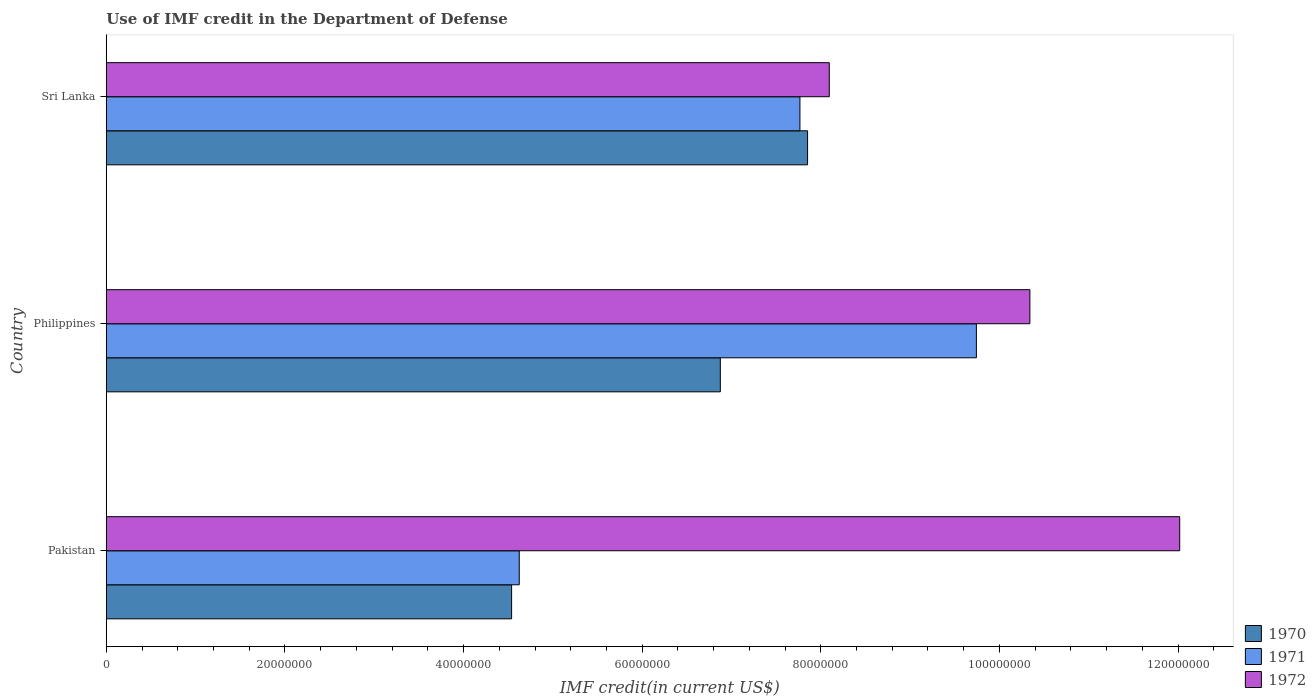How many different coloured bars are there?
Keep it short and to the point. 3. Are the number of bars per tick equal to the number of legend labels?
Provide a succinct answer. Yes. Are the number of bars on each tick of the Y-axis equal?
Make the answer very short. Yes. What is the label of the 3rd group of bars from the top?
Keep it short and to the point. Pakistan. What is the IMF credit in the Department of Defense in 1971 in Sri Lanka?
Ensure brevity in your answer.  7.77e+07. Across all countries, what is the maximum IMF credit in the Department of Defense in 1971?
Your response must be concise. 9.74e+07. Across all countries, what is the minimum IMF credit in the Department of Defense in 1972?
Keep it short and to the point. 8.10e+07. What is the total IMF credit in the Department of Defense in 1971 in the graph?
Your answer should be compact. 2.21e+08. What is the difference between the IMF credit in the Department of Defense in 1970 in Pakistan and that in Sri Lanka?
Your answer should be very brief. -3.31e+07. What is the difference between the IMF credit in the Department of Defense in 1971 in Sri Lanka and the IMF credit in the Department of Defense in 1970 in Philippines?
Your answer should be very brief. 8.91e+06. What is the average IMF credit in the Department of Defense in 1972 per country?
Your response must be concise. 1.02e+08. What is the difference between the IMF credit in the Department of Defense in 1970 and IMF credit in the Department of Defense in 1971 in Sri Lanka?
Provide a short and direct response. 8.56e+05. What is the ratio of the IMF credit in the Department of Defense in 1971 in Pakistan to that in Philippines?
Keep it short and to the point. 0.47. Is the difference between the IMF credit in the Department of Defense in 1970 in Philippines and Sri Lanka greater than the difference between the IMF credit in the Department of Defense in 1971 in Philippines and Sri Lanka?
Your response must be concise. No. What is the difference between the highest and the second highest IMF credit in the Department of Defense in 1972?
Make the answer very short. 1.68e+07. What is the difference between the highest and the lowest IMF credit in the Department of Defense in 1971?
Ensure brevity in your answer.  5.12e+07. In how many countries, is the IMF credit in the Department of Defense in 1972 greater than the average IMF credit in the Department of Defense in 1972 taken over all countries?
Your answer should be very brief. 2. Is the sum of the IMF credit in the Department of Defense in 1971 in Pakistan and Sri Lanka greater than the maximum IMF credit in the Department of Defense in 1970 across all countries?
Ensure brevity in your answer.  Yes. What does the 2nd bar from the bottom in Sri Lanka represents?
Give a very brief answer. 1971. Is it the case that in every country, the sum of the IMF credit in the Department of Defense in 1970 and IMF credit in the Department of Defense in 1971 is greater than the IMF credit in the Department of Defense in 1972?
Give a very brief answer. No. How many countries are there in the graph?
Offer a terse response. 3. Does the graph contain any zero values?
Your answer should be compact. No. Where does the legend appear in the graph?
Offer a very short reply. Bottom right. How many legend labels are there?
Give a very brief answer. 3. How are the legend labels stacked?
Give a very brief answer. Vertical. What is the title of the graph?
Keep it short and to the point. Use of IMF credit in the Department of Defense. Does "2002" appear as one of the legend labels in the graph?
Keep it short and to the point. No. What is the label or title of the X-axis?
Give a very brief answer. IMF credit(in current US$). What is the IMF credit(in current US$) in 1970 in Pakistan?
Offer a very short reply. 4.54e+07. What is the IMF credit(in current US$) in 1971 in Pakistan?
Your answer should be very brief. 4.62e+07. What is the IMF credit(in current US$) of 1972 in Pakistan?
Provide a short and direct response. 1.20e+08. What is the IMF credit(in current US$) in 1970 in Philippines?
Your answer should be compact. 6.88e+07. What is the IMF credit(in current US$) of 1971 in Philippines?
Offer a terse response. 9.74e+07. What is the IMF credit(in current US$) in 1972 in Philippines?
Your answer should be very brief. 1.03e+08. What is the IMF credit(in current US$) in 1970 in Sri Lanka?
Offer a terse response. 7.85e+07. What is the IMF credit(in current US$) of 1971 in Sri Lanka?
Keep it short and to the point. 7.77e+07. What is the IMF credit(in current US$) in 1972 in Sri Lanka?
Your response must be concise. 8.10e+07. Across all countries, what is the maximum IMF credit(in current US$) in 1970?
Keep it short and to the point. 7.85e+07. Across all countries, what is the maximum IMF credit(in current US$) in 1971?
Ensure brevity in your answer.  9.74e+07. Across all countries, what is the maximum IMF credit(in current US$) of 1972?
Offer a very short reply. 1.20e+08. Across all countries, what is the minimum IMF credit(in current US$) of 1970?
Your answer should be compact. 4.54e+07. Across all countries, what is the minimum IMF credit(in current US$) of 1971?
Provide a succinct answer. 4.62e+07. Across all countries, what is the minimum IMF credit(in current US$) in 1972?
Your answer should be compact. 8.10e+07. What is the total IMF credit(in current US$) in 1970 in the graph?
Offer a terse response. 1.93e+08. What is the total IMF credit(in current US$) in 1971 in the graph?
Your response must be concise. 2.21e+08. What is the total IMF credit(in current US$) in 1972 in the graph?
Offer a very short reply. 3.05e+08. What is the difference between the IMF credit(in current US$) in 1970 in Pakistan and that in Philippines?
Offer a terse response. -2.34e+07. What is the difference between the IMF credit(in current US$) of 1971 in Pakistan and that in Philippines?
Keep it short and to the point. -5.12e+07. What is the difference between the IMF credit(in current US$) of 1972 in Pakistan and that in Philippines?
Offer a terse response. 1.68e+07. What is the difference between the IMF credit(in current US$) of 1970 in Pakistan and that in Sri Lanka?
Your answer should be very brief. -3.31e+07. What is the difference between the IMF credit(in current US$) in 1971 in Pakistan and that in Sri Lanka?
Your answer should be compact. -3.14e+07. What is the difference between the IMF credit(in current US$) of 1972 in Pakistan and that in Sri Lanka?
Make the answer very short. 3.92e+07. What is the difference between the IMF credit(in current US$) of 1970 in Philippines and that in Sri Lanka?
Offer a terse response. -9.77e+06. What is the difference between the IMF credit(in current US$) of 1971 in Philippines and that in Sri Lanka?
Your answer should be very brief. 1.98e+07. What is the difference between the IMF credit(in current US$) in 1972 in Philippines and that in Sri Lanka?
Provide a short and direct response. 2.25e+07. What is the difference between the IMF credit(in current US$) in 1970 in Pakistan and the IMF credit(in current US$) in 1971 in Philippines?
Your answer should be very brief. -5.20e+07. What is the difference between the IMF credit(in current US$) of 1970 in Pakistan and the IMF credit(in current US$) of 1972 in Philippines?
Offer a very short reply. -5.80e+07. What is the difference between the IMF credit(in current US$) of 1971 in Pakistan and the IMF credit(in current US$) of 1972 in Philippines?
Keep it short and to the point. -5.72e+07. What is the difference between the IMF credit(in current US$) in 1970 in Pakistan and the IMF credit(in current US$) in 1971 in Sri Lanka?
Offer a very short reply. -3.23e+07. What is the difference between the IMF credit(in current US$) in 1970 in Pakistan and the IMF credit(in current US$) in 1972 in Sri Lanka?
Keep it short and to the point. -3.56e+07. What is the difference between the IMF credit(in current US$) in 1971 in Pakistan and the IMF credit(in current US$) in 1972 in Sri Lanka?
Make the answer very short. -3.47e+07. What is the difference between the IMF credit(in current US$) in 1970 in Philippines and the IMF credit(in current US$) in 1971 in Sri Lanka?
Provide a short and direct response. -8.91e+06. What is the difference between the IMF credit(in current US$) of 1970 in Philippines and the IMF credit(in current US$) of 1972 in Sri Lanka?
Ensure brevity in your answer.  -1.22e+07. What is the difference between the IMF credit(in current US$) in 1971 in Philippines and the IMF credit(in current US$) in 1972 in Sri Lanka?
Give a very brief answer. 1.65e+07. What is the average IMF credit(in current US$) of 1970 per country?
Your response must be concise. 6.42e+07. What is the average IMF credit(in current US$) of 1971 per country?
Your answer should be compact. 7.38e+07. What is the average IMF credit(in current US$) in 1972 per country?
Provide a short and direct response. 1.02e+08. What is the difference between the IMF credit(in current US$) in 1970 and IMF credit(in current US$) in 1971 in Pakistan?
Give a very brief answer. -8.56e+05. What is the difference between the IMF credit(in current US$) in 1970 and IMF credit(in current US$) in 1972 in Pakistan?
Your answer should be very brief. -7.48e+07. What is the difference between the IMF credit(in current US$) of 1971 and IMF credit(in current US$) of 1972 in Pakistan?
Your answer should be compact. -7.40e+07. What is the difference between the IMF credit(in current US$) of 1970 and IMF credit(in current US$) of 1971 in Philippines?
Offer a very short reply. -2.87e+07. What is the difference between the IMF credit(in current US$) in 1970 and IMF credit(in current US$) in 1972 in Philippines?
Make the answer very short. -3.47e+07. What is the difference between the IMF credit(in current US$) in 1971 and IMF credit(in current US$) in 1972 in Philippines?
Your answer should be compact. -5.99e+06. What is the difference between the IMF credit(in current US$) in 1970 and IMF credit(in current US$) in 1971 in Sri Lanka?
Provide a short and direct response. 8.56e+05. What is the difference between the IMF credit(in current US$) of 1970 and IMF credit(in current US$) of 1972 in Sri Lanka?
Provide a short and direct response. -2.43e+06. What is the difference between the IMF credit(in current US$) in 1971 and IMF credit(in current US$) in 1972 in Sri Lanka?
Give a very brief answer. -3.29e+06. What is the ratio of the IMF credit(in current US$) in 1970 in Pakistan to that in Philippines?
Ensure brevity in your answer.  0.66. What is the ratio of the IMF credit(in current US$) in 1971 in Pakistan to that in Philippines?
Ensure brevity in your answer.  0.47. What is the ratio of the IMF credit(in current US$) of 1972 in Pakistan to that in Philippines?
Your answer should be compact. 1.16. What is the ratio of the IMF credit(in current US$) of 1970 in Pakistan to that in Sri Lanka?
Your answer should be very brief. 0.58. What is the ratio of the IMF credit(in current US$) in 1971 in Pakistan to that in Sri Lanka?
Give a very brief answer. 0.6. What is the ratio of the IMF credit(in current US$) in 1972 in Pakistan to that in Sri Lanka?
Your answer should be very brief. 1.48. What is the ratio of the IMF credit(in current US$) of 1970 in Philippines to that in Sri Lanka?
Provide a short and direct response. 0.88. What is the ratio of the IMF credit(in current US$) in 1971 in Philippines to that in Sri Lanka?
Provide a short and direct response. 1.25. What is the ratio of the IMF credit(in current US$) of 1972 in Philippines to that in Sri Lanka?
Your response must be concise. 1.28. What is the difference between the highest and the second highest IMF credit(in current US$) in 1970?
Ensure brevity in your answer.  9.77e+06. What is the difference between the highest and the second highest IMF credit(in current US$) in 1971?
Your answer should be compact. 1.98e+07. What is the difference between the highest and the second highest IMF credit(in current US$) of 1972?
Make the answer very short. 1.68e+07. What is the difference between the highest and the lowest IMF credit(in current US$) in 1970?
Give a very brief answer. 3.31e+07. What is the difference between the highest and the lowest IMF credit(in current US$) in 1971?
Give a very brief answer. 5.12e+07. What is the difference between the highest and the lowest IMF credit(in current US$) of 1972?
Your response must be concise. 3.92e+07. 